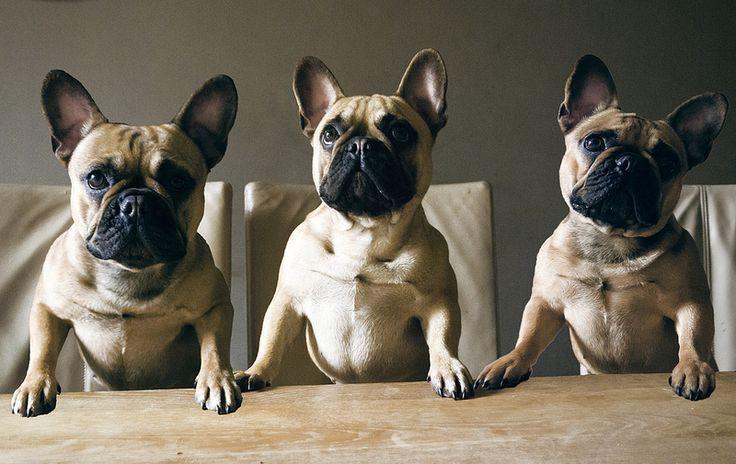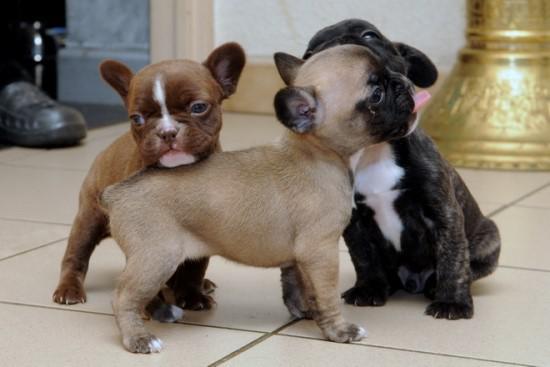The first image is the image on the left, the second image is the image on the right. Considering the images on both sides, is "An image shows a horizontal row of three similarly colored dogs in similar poses." valid? Answer yes or no. Yes. The first image is the image on the left, the second image is the image on the right. Assess this claim about the two images: "In one of the images, the dogs are standing on the pavement outside.". Correct or not? Answer yes or no. No. 